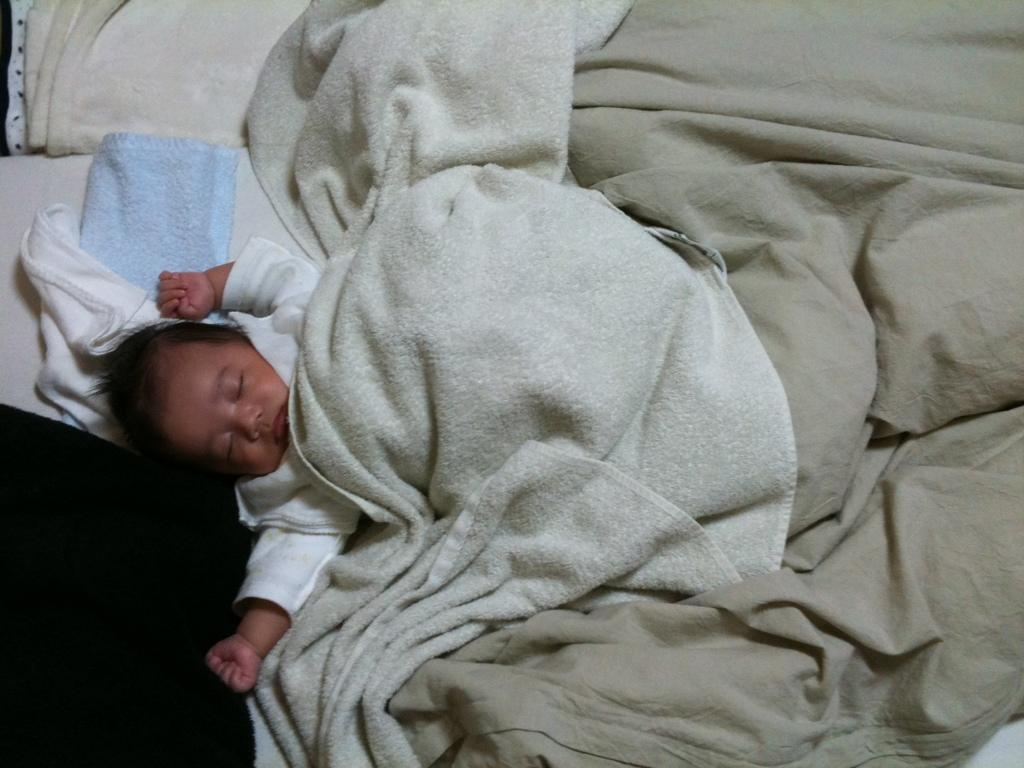What is the main subject of the image? There is a baby in the image. Where is the baby located? The baby is lying on a bed. What is covering the baby? The baby is covered by a blanket. What is the taste of the blanket in the image? The blanket does not have a taste, as it is an inanimate object. 